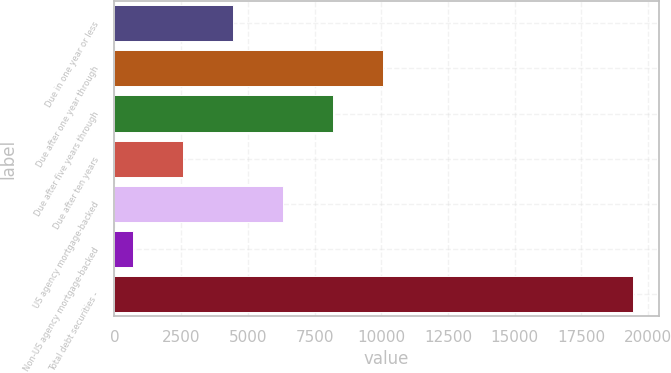Convert chart. <chart><loc_0><loc_0><loc_500><loc_500><bar_chart><fcel>Due in one year or less<fcel>Due after one year through<fcel>Due after five years through<fcel>Due after ten years<fcel>US agency mortgage-backed<fcel>Non-US agency mortgage-backed<fcel>Total debt securities -<nl><fcel>4447<fcel>10064.5<fcel>8192<fcel>2574.5<fcel>6319.5<fcel>702<fcel>19427<nl></chart> 